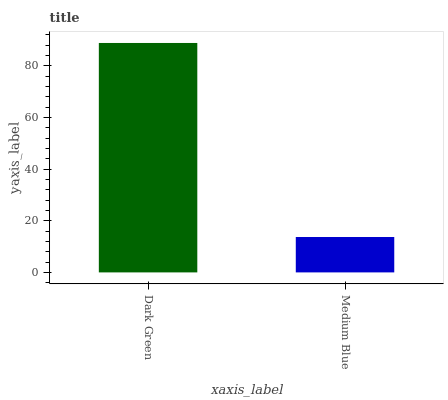Is Medium Blue the minimum?
Answer yes or no. Yes. Is Dark Green the maximum?
Answer yes or no. Yes. Is Medium Blue the maximum?
Answer yes or no. No. Is Dark Green greater than Medium Blue?
Answer yes or no. Yes. Is Medium Blue less than Dark Green?
Answer yes or no. Yes. Is Medium Blue greater than Dark Green?
Answer yes or no. No. Is Dark Green less than Medium Blue?
Answer yes or no. No. Is Dark Green the high median?
Answer yes or no. Yes. Is Medium Blue the low median?
Answer yes or no. Yes. Is Medium Blue the high median?
Answer yes or no. No. Is Dark Green the low median?
Answer yes or no. No. 